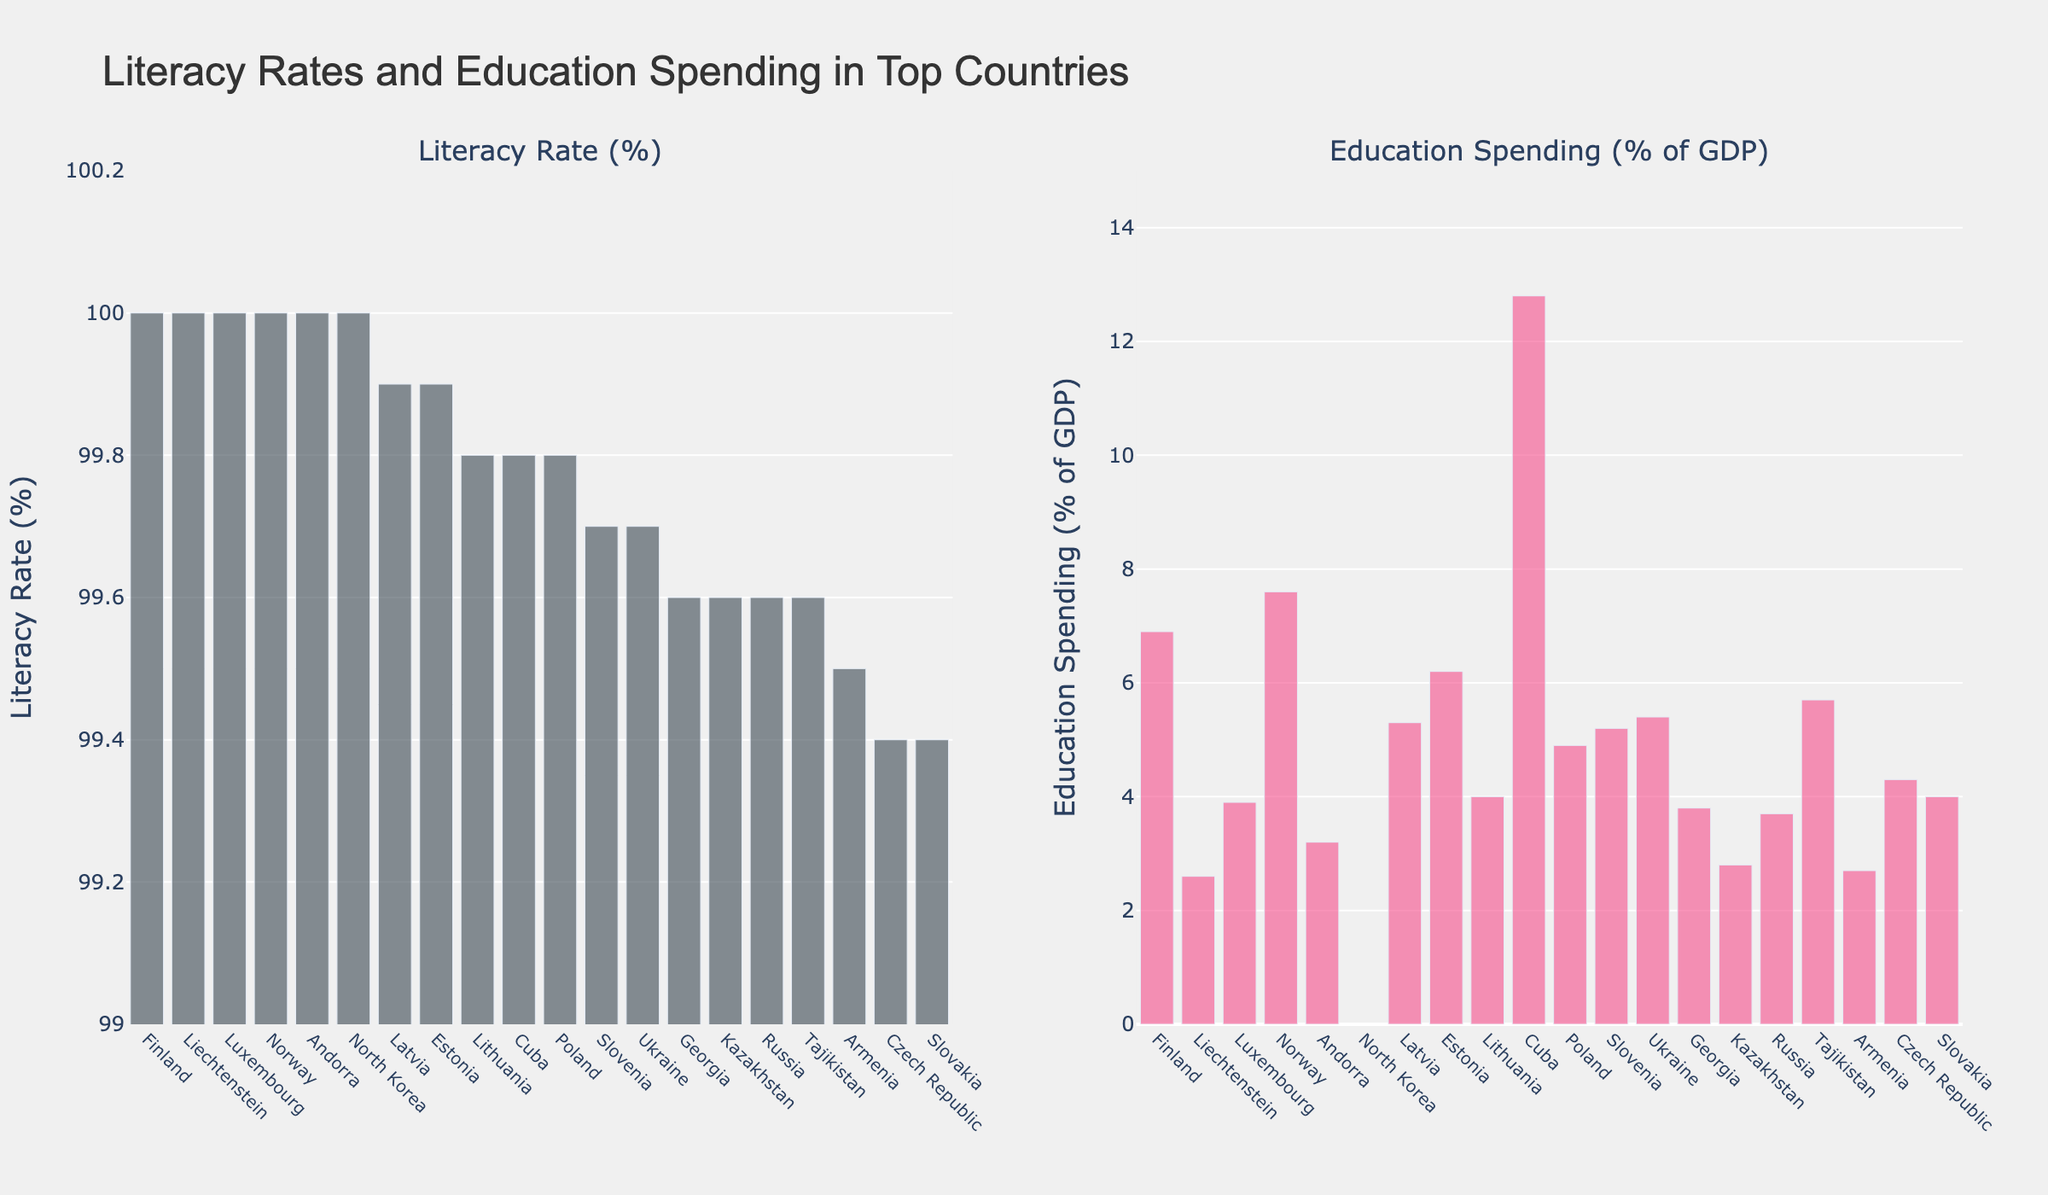Which country spends the highest percentage of GDP on education? The bar chart on the right represents education spending. By examining the lengths of the bars, Cuba has the tallest bar in education spending.
Answer: Cuba Which country has a literacy rate that is both 99.6% and spends the least on education as a percentage of GDP? The bar chart on the left shows that several countries have a literacy rate of 99.6%. Among these (Georgia, Kazakhstan, Russia, Tajikistan), Kazakhstan has the shortest bar in the education spending chart.
Answer: Kazakhstan Which of the top 10 literate countries has almost the highest education spending, and what is the percentage? The right bar chart indicates that Norway has the second tallest bar right after Cuba in education spending.
Answer: Norway, 7.6% What is the difference in education spending between Finland and Tajikistan? The two bars corresponding to Finland and Tajikistan in the right chart show education spending of 6.9% and 5.7%, respectively. The difference is 6.9 - 5.7.
Answer: 1.2% In which section of the charts (left or right) do you see uniform-colored bars, and what does the color represent? Both the bar charts are uniform in color; the left bar chart (Literacy Rate) is grey, while the right bar chart (Education Spending) is pink.
Answer: Left - Literacy Rate: grey, Right - Education Spending: pink 